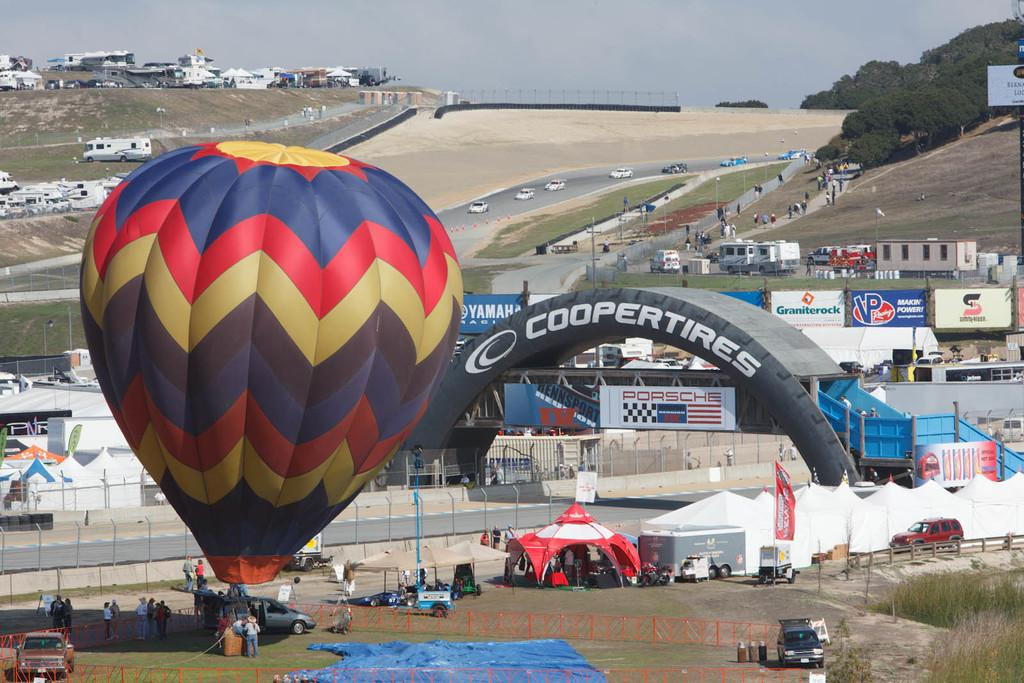<image>
Render a clear and concise summary of the photo. The Cooper Tires company is involved in a hot air balloon event 